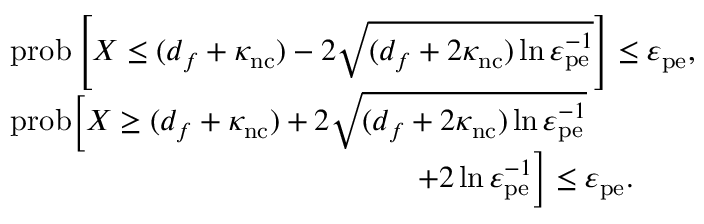<formula> <loc_0><loc_0><loc_500><loc_500>\begin{array} { r l } & { p r o b \left [ X \leq ( d _ { f } + \kappa _ { n c } ) - 2 \sqrt { ( d _ { f } + 2 \kappa _ { n c } ) \ln \varepsilon _ { p e } ^ { - 1 } } \right ] \leq \varepsilon _ { p e } , } \\ & { p r o b \left [ X \geq ( d _ { f } + \kappa _ { n c } ) + 2 \sqrt { ( d _ { f } + 2 \kappa _ { n c } ) \ln \varepsilon _ { p e } ^ { - 1 } } } \\ & { + 2 \ln \varepsilon _ { p e } ^ { - 1 } \right ] \leq \varepsilon _ { p e } . } \end{array}</formula> 